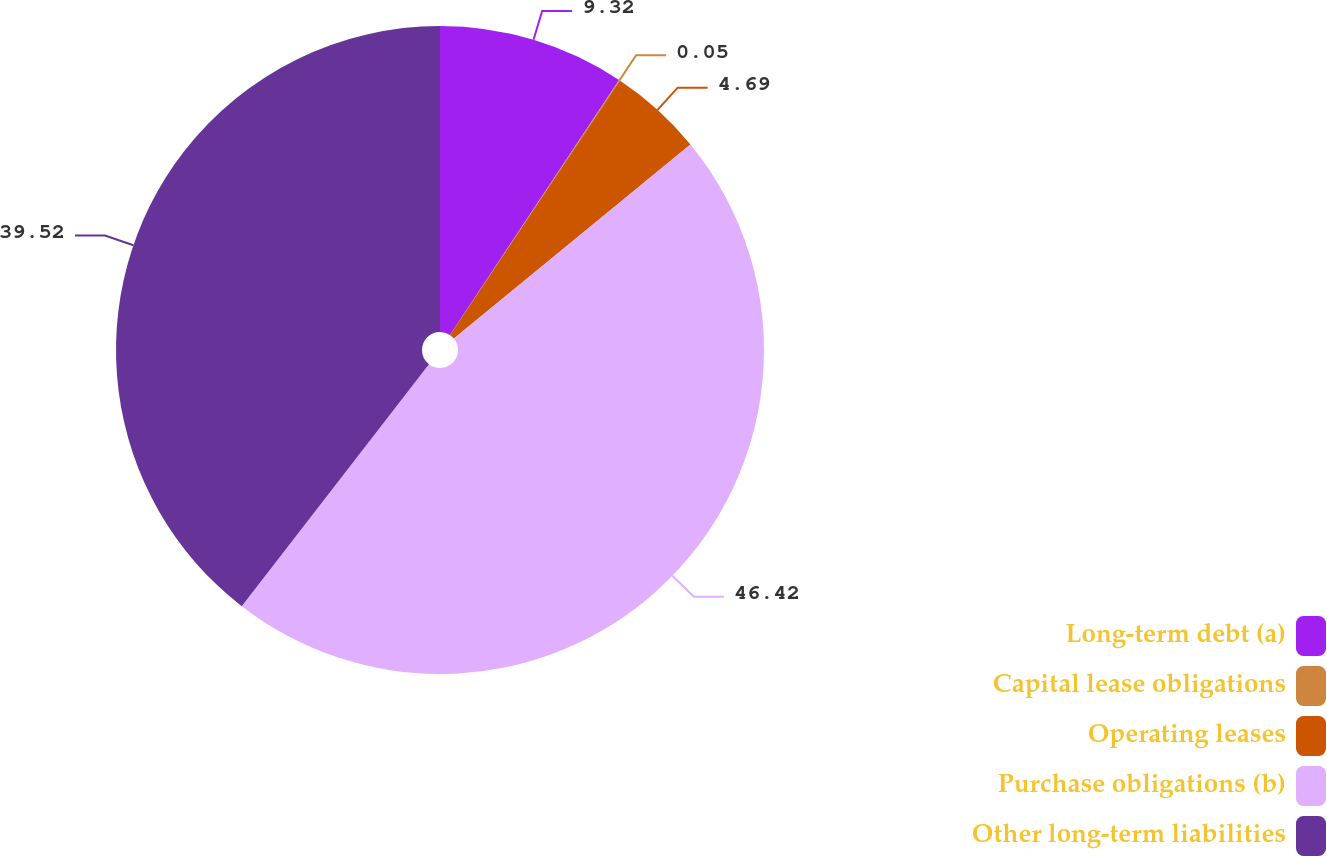Convert chart. <chart><loc_0><loc_0><loc_500><loc_500><pie_chart><fcel>Long-term debt (a)<fcel>Capital lease obligations<fcel>Operating leases<fcel>Purchase obligations (b)<fcel>Other long-term liabilities<nl><fcel>9.32%<fcel>0.05%<fcel>4.69%<fcel>46.42%<fcel>39.52%<nl></chart> 